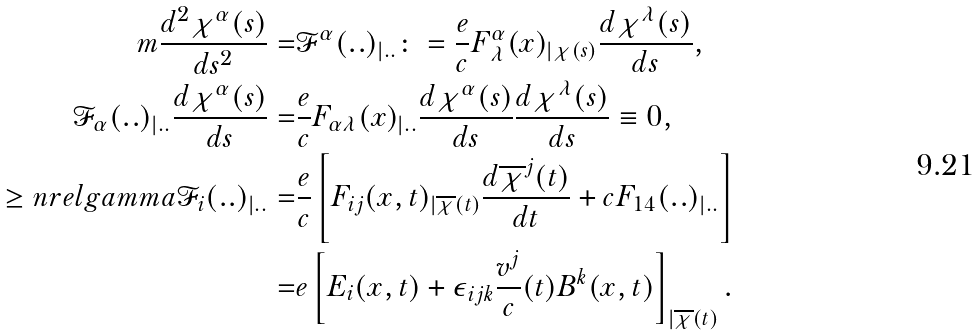Convert formula to latex. <formula><loc_0><loc_0><loc_500><loc_500>m \frac { d ^ { 2 } \chi ^ { \alpha } ( s ) } { d s ^ { 2 } } = & \mathcal { F } ^ { \alpha } ( . . ) _ { | . . } \colon = \frac { e } { c } F ^ { \alpha } _ { \, \lambda } ( x ) _ { | \chi ( s ) } \frac { d \chi ^ { \lambda } ( s ) } { d s } , \\ \mathcal { F } _ { \alpha } ( . . ) _ { | . . } \frac { d \chi ^ { \alpha } ( s ) } { d s } = & \frac { e } { c } F _ { \alpha \lambda } ( x ) _ { | . . } \frac { d \chi ^ { \alpha } ( s ) } { d s } \frac { d \chi ^ { \lambda } ( s ) } { d s } \equiv 0 , \\ \geq n r e l g a m m a \mathcal { F } _ { i } ( . . ) _ { | . . } = & \frac { e } { c } \left [ F _ { i j } ( x , t ) _ { | \overline { \chi } ( t ) } \frac { d \overline { \chi } ^ { j } ( t ) } { d t } + c F _ { 1 4 } ( . . ) _ { | . . } \right ] \\ = & e \left [ E _ { i } ( x , t ) + \epsilon _ { i j k } \frac { v ^ { j } } { c } ( t ) B ^ { k } ( x , t ) \right ] _ { | \overline { \chi } ( t ) } .</formula> 